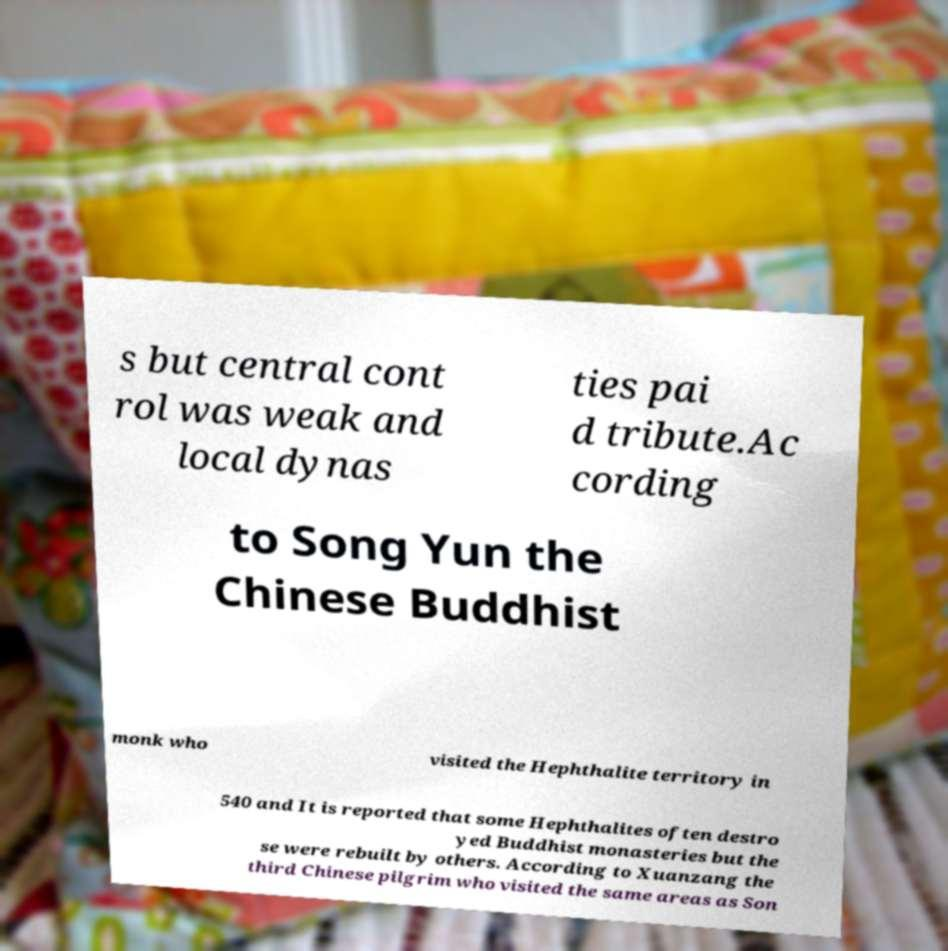There's text embedded in this image that I need extracted. Can you transcribe it verbatim? s but central cont rol was weak and local dynas ties pai d tribute.Ac cording to Song Yun the Chinese Buddhist monk who visited the Hephthalite territory in 540 and It is reported that some Hephthalites often destro yed Buddhist monasteries but the se were rebuilt by others. According to Xuanzang the third Chinese pilgrim who visited the same areas as Son 